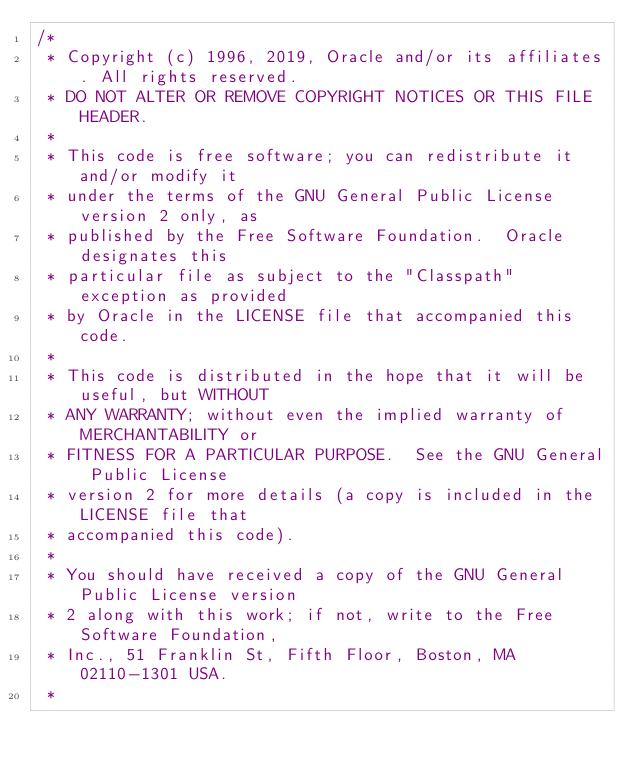Convert code to text. <code><loc_0><loc_0><loc_500><loc_500><_Java_>/*
 * Copyright (c) 1996, 2019, Oracle and/or its affiliates. All rights reserved.
 * DO NOT ALTER OR REMOVE COPYRIGHT NOTICES OR THIS FILE HEADER.
 *
 * This code is free software; you can redistribute it and/or modify it
 * under the terms of the GNU General Public License version 2 only, as
 * published by the Free Software Foundation.  Oracle designates this
 * particular file as subject to the "Classpath" exception as provided
 * by Oracle in the LICENSE file that accompanied this code.
 *
 * This code is distributed in the hope that it will be useful, but WITHOUT
 * ANY WARRANTY; without even the implied warranty of MERCHANTABILITY or
 * FITNESS FOR A PARTICULAR PURPOSE.  See the GNU General Public License
 * version 2 for more details (a copy is included in the LICENSE file that
 * accompanied this code).
 *
 * You should have received a copy of the GNU General Public License version
 * 2 along with this work; if not, write to the Free Software Foundation,
 * Inc., 51 Franklin St, Fifth Floor, Boston, MA 02110-1301 USA.
 *</code> 